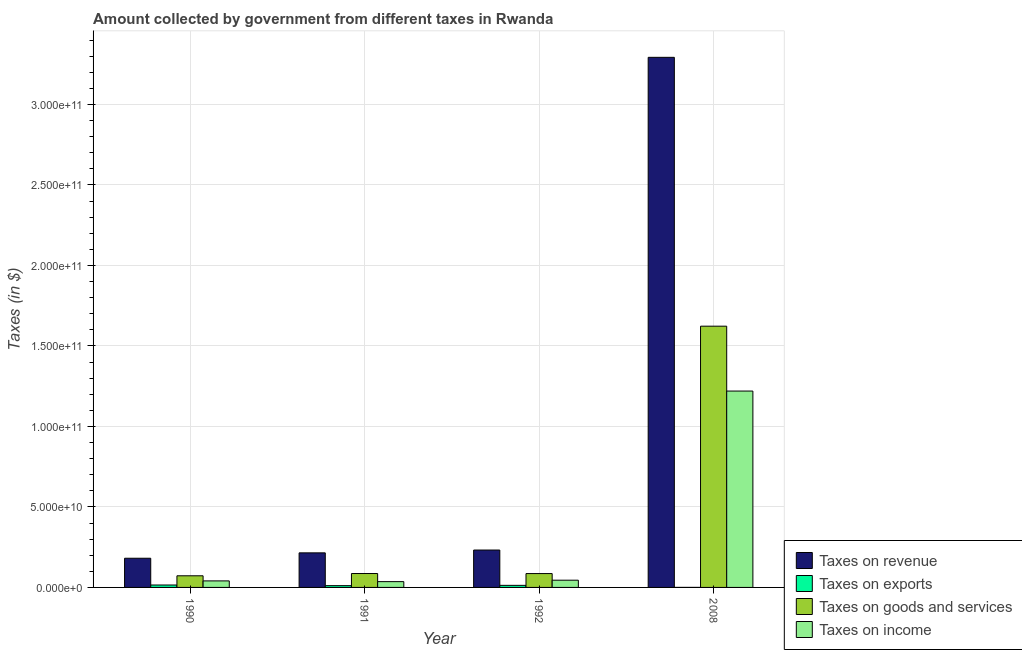How many different coloured bars are there?
Give a very brief answer. 4. How many groups of bars are there?
Offer a very short reply. 4. How many bars are there on the 2nd tick from the left?
Keep it short and to the point. 4. How many bars are there on the 3rd tick from the right?
Provide a succinct answer. 4. What is the amount collected as tax on income in 1992?
Your response must be concise. 4.49e+09. Across all years, what is the maximum amount collected as tax on revenue?
Offer a terse response. 3.29e+11. Across all years, what is the minimum amount collected as tax on exports?
Give a very brief answer. 1.73e+07. In which year was the amount collected as tax on income minimum?
Provide a short and direct response. 1991. What is the total amount collected as tax on goods in the graph?
Provide a succinct answer. 1.87e+11. What is the difference between the amount collected as tax on revenue in 1992 and that in 2008?
Keep it short and to the point. -3.06e+11. What is the difference between the amount collected as tax on goods in 1992 and the amount collected as tax on income in 1990?
Make the answer very short. 1.38e+09. What is the average amount collected as tax on income per year?
Your answer should be very brief. 3.35e+1. What is the ratio of the amount collected as tax on income in 1992 to that in 2008?
Your answer should be very brief. 0.04. Is the difference between the amount collected as tax on exports in 1991 and 1992 greater than the difference between the amount collected as tax on income in 1991 and 1992?
Your response must be concise. No. What is the difference between the highest and the second highest amount collected as tax on exports?
Your answer should be very brief. 2.14e+08. What is the difference between the highest and the lowest amount collected as tax on goods?
Give a very brief answer. 1.55e+11. In how many years, is the amount collected as tax on exports greater than the average amount collected as tax on exports taken over all years?
Provide a short and direct response. 3. Is the sum of the amount collected as tax on revenue in 1991 and 2008 greater than the maximum amount collected as tax on exports across all years?
Make the answer very short. Yes. Is it the case that in every year, the sum of the amount collected as tax on exports and amount collected as tax on income is greater than the sum of amount collected as tax on goods and amount collected as tax on revenue?
Offer a terse response. No. What does the 1st bar from the left in 1991 represents?
Give a very brief answer. Taxes on revenue. What does the 3rd bar from the right in 1990 represents?
Provide a succinct answer. Taxes on exports. Is it the case that in every year, the sum of the amount collected as tax on revenue and amount collected as tax on exports is greater than the amount collected as tax on goods?
Offer a very short reply. Yes. What is the difference between two consecutive major ticks on the Y-axis?
Give a very brief answer. 5.00e+1. Are the values on the major ticks of Y-axis written in scientific E-notation?
Provide a succinct answer. Yes. Does the graph contain grids?
Your answer should be very brief. Yes. Where does the legend appear in the graph?
Keep it short and to the point. Bottom right. How many legend labels are there?
Provide a succinct answer. 4. What is the title of the graph?
Provide a short and direct response. Amount collected by government from different taxes in Rwanda. Does "Natural Gas" appear as one of the legend labels in the graph?
Your response must be concise. No. What is the label or title of the Y-axis?
Offer a terse response. Taxes (in $). What is the Taxes (in $) of Taxes on revenue in 1990?
Ensure brevity in your answer.  1.81e+1. What is the Taxes (in $) in Taxes on exports in 1990?
Offer a terse response. 1.51e+09. What is the Taxes (in $) in Taxes on goods and services in 1990?
Your answer should be compact. 7.23e+09. What is the Taxes (in $) in Taxes on income in 1990?
Provide a short and direct response. 4.06e+09. What is the Taxes (in $) of Taxes on revenue in 1991?
Offer a terse response. 2.15e+1. What is the Taxes (in $) of Taxes on exports in 1991?
Your answer should be very brief. 1.11e+09. What is the Taxes (in $) in Taxes on goods and services in 1991?
Offer a terse response. 8.63e+09. What is the Taxes (in $) of Taxes on income in 1991?
Provide a short and direct response. 3.60e+09. What is the Taxes (in $) of Taxes on revenue in 1992?
Ensure brevity in your answer.  2.32e+1. What is the Taxes (in $) of Taxes on exports in 1992?
Your answer should be compact. 1.29e+09. What is the Taxes (in $) in Taxes on goods and services in 1992?
Ensure brevity in your answer.  8.60e+09. What is the Taxes (in $) in Taxes on income in 1992?
Your response must be concise. 4.49e+09. What is the Taxes (in $) in Taxes on revenue in 2008?
Ensure brevity in your answer.  3.29e+11. What is the Taxes (in $) in Taxes on exports in 2008?
Your answer should be very brief. 1.73e+07. What is the Taxes (in $) of Taxes on goods and services in 2008?
Keep it short and to the point. 1.62e+11. What is the Taxes (in $) in Taxes on income in 2008?
Your answer should be very brief. 1.22e+11. Across all years, what is the maximum Taxes (in $) in Taxes on revenue?
Make the answer very short. 3.29e+11. Across all years, what is the maximum Taxes (in $) in Taxes on exports?
Provide a short and direct response. 1.51e+09. Across all years, what is the maximum Taxes (in $) of Taxes on goods and services?
Ensure brevity in your answer.  1.62e+11. Across all years, what is the maximum Taxes (in $) in Taxes on income?
Your answer should be very brief. 1.22e+11. Across all years, what is the minimum Taxes (in $) of Taxes on revenue?
Ensure brevity in your answer.  1.81e+1. Across all years, what is the minimum Taxes (in $) of Taxes on exports?
Give a very brief answer. 1.73e+07. Across all years, what is the minimum Taxes (in $) in Taxes on goods and services?
Provide a succinct answer. 7.23e+09. Across all years, what is the minimum Taxes (in $) in Taxes on income?
Your response must be concise. 3.60e+09. What is the total Taxes (in $) in Taxes on revenue in the graph?
Ensure brevity in your answer.  3.92e+11. What is the total Taxes (in $) in Taxes on exports in the graph?
Make the answer very short. 3.92e+09. What is the total Taxes (in $) in Taxes on goods and services in the graph?
Ensure brevity in your answer.  1.87e+11. What is the total Taxes (in $) of Taxes on income in the graph?
Ensure brevity in your answer.  1.34e+11. What is the difference between the Taxes (in $) of Taxes on revenue in 1990 and that in 1991?
Your answer should be very brief. -3.34e+09. What is the difference between the Taxes (in $) in Taxes on exports in 1990 and that in 1991?
Make the answer very short. 3.99e+08. What is the difference between the Taxes (in $) of Taxes on goods and services in 1990 and that in 1991?
Your answer should be compact. -1.40e+09. What is the difference between the Taxes (in $) in Taxes on income in 1990 and that in 1991?
Give a very brief answer. 4.54e+08. What is the difference between the Taxes (in $) in Taxes on revenue in 1990 and that in 1992?
Offer a terse response. -5.09e+09. What is the difference between the Taxes (in $) in Taxes on exports in 1990 and that in 1992?
Your answer should be compact. 2.14e+08. What is the difference between the Taxes (in $) of Taxes on goods and services in 1990 and that in 1992?
Your answer should be very brief. -1.38e+09. What is the difference between the Taxes (in $) in Taxes on income in 1990 and that in 1992?
Ensure brevity in your answer.  -4.31e+08. What is the difference between the Taxes (in $) in Taxes on revenue in 1990 and that in 2008?
Provide a succinct answer. -3.11e+11. What is the difference between the Taxes (in $) in Taxes on exports in 1990 and that in 2008?
Give a very brief answer. 1.49e+09. What is the difference between the Taxes (in $) of Taxes on goods and services in 1990 and that in 2008?
Provide a short and direct response. -1.55e+11. What is the difference between the Taxes (in $) in Taxes on income in 1990 and that in 2008?
Your answer should be very brief. -1.18e+11. What is the difference between the Taxes (in $) in Taxes on revenue in 1991 and that in 1992?
Provide a short and direct response. -1.75e+09. What is the difference between the Taxes (in $) of Taxes on exports in 1991 and that in 1992?
Your answer should be very brief. -1.85e+08. What is the difference between the Taxes (in $) in Taxes on goods and services in 1991 and that in 1992?
Provide a succinct answer. 2.90e+07. What is the difference between the Taxes (in $) in Taxes on income in 1991 and that in 1992?
Your answer should be very brief. -8.85e+08. What is the difference between the Taxes (in $) of Taxes on revenue in 1991 and that in 2008?
Offer a terse response. -3.08e+11. What is the difference between the Taxes (in $) in Taxes on exports in 1991 and that in 2008?
Offer a terse response. 1.09e+09. What is the difference between the Taxes (in $) of Taxes on goods and services in 1991 and that in 2008?
Offer a terse response. -1.54e+11. What is the difference between the Taxes (in $) of Taxes on income in 1991 and that in 2008?
Give a very brief answer. -1.18e+11. What is the difference between the Taxes (in $) in Taxes on revenue in 1992 and that in 2008?
Make the answer very short. -3.06e+11. What is the difference between the Taxes (in $) in Taxes on exports in 1992 and that in 2008?
Give a very brief answer. 1.27e+09. What is the difference between the Taxes (in $) of Taxes on goods and services in 1992 and that in 2008?
Offer a terse response. -1.54e+11. What is the difference between the Taxes (in $) of Taxes on income in 1992 and that in 2008?
Keep it short and to the point. -1.17e+11. What is the difference between the Taxes (in $) in Taxes on revenue in 1990 and the Taxes (in $) in Taxes on exports in 1991?
Give a very brief answer. 1.70e+1. What is the difference between the Taxes (in $) in Taxes on revenue in 1990 and the Taxes (in $) in Taxes on goods and services in 1991?
Your response must be concise. 9.50e+09. What is the difference between the Taxes (in $) of Taxes on revenue in 1990 and the Taxes (in $) of Taxes on income in 1991?
Keep it short and to the point. 1.45e+1. What is the difference between the Taxes (in $) of Taxes on exports in 1990 and the Taxes (in $) of Taxes on goods and services in 1991?
Your answer should be very brief. -7.13e+09. What is the difference between the Taxes (in $) of Taxes on exports in 1990 and the Taxes (in $) of Taxes on income in 1991?
Make the answer very short. -2.10e+09. What is the difference between the Taxes (in $) of Taxes on goods and services in 1990 and the Taxes (in $) of Taxes on income in 1991?
Your answer should be compact. 3.63e+09. What is the difference between the Taxes (in $) of Taxes on revenue in 1990 and the Taxes (in $) of Taxes on exports in 1992?
Give a very brief answer. 1.68e+1. What is the difference between the Taxes (in $) of Taxes on revenue in 1990 and the Taxes (in $) of Taxes on goods and services in 1992?
Provide a succinct answer. 9.52e+09. What is the difference between the Taxes (in $) of Taxes on revenue in 1990 and the Taxes (in $) of Taxes on income in 1992?
Provide a short and direct response. 1.36e+1. What is the difference between the Taxes (in $) of Taxes on exports in 1990 and the Taxes (in $) of Taxes on goods and services in 1992?
Provide a short and direct response. -7.10e+09. What is the difference between the Taxes (in $) in Taxes on exports in 1990 and the Taxes (in $) in Taxes on income in 1992?
Provide a succinct answer. -2.98e+09. What is the difference between the Taxes (in $) in Taxes on goods and services in 1990 and the Taxes (in $) in Taxes on income in 1992?
Make the answer very short. 2.74e+09. What is the difference between the Taxes (in $) of Taxes on revenue in 1990 and the Taxes (in $) of Taxes on exports in 2008?
Make the answer very short. 1.81e+1. What is the difference between the Taxes (in $) of Taxes on revenue in 1990 and the Taxes (in $) of Taxes on goods and services in 2008?
Offer a very short reply. -1.44e+11. What is the difference between the Taxes (in $) of Taxes on revenue in 1990 and the Taxes (in $) of Taxes on income in 2008?
Ensure brevity in your answer.  -1.04e+11. What is the difference between the Taxes (in $) in Taxes on exports in 1990 and the Taxes (in $) in Taxes on goods and services in 2008?
Make the answer very short. -1.61e+11. What is the difference between the Taxes (in $) of Taxes on exports in 1990 and the Taxes (in $) of Taxes on income in 2008?
Make the answer very short. -1.20e+11. What is the difference between the Taxes (in $) of Taxes on goods and services in 1990 and the Taxes (in $) of Taxes on income in 2008?
Your response must be concise. -1.15e+11. What is the difference between the Taxes (in $) in Taxes on revenue in 1991 and the Taxes (in $) in Taxes on exports in 1992?
Offer a very short reply. 2.02e+1. What is the difference between the Taxes (in $) in Taxes on revenue in 1991 and the Taxes (in $) in Taxes on goods and services in 1992?
Offer a very short reply. 1.29e+1. What is the difference between the Taxes (in $) of Taxes on revenue in 1991 and the Taxes (in $) of Taxes on income in 1992?
Keep it short and to the point. 1.70e+1. What is the difference between the Taxes (in $) of Taxes on exports in 1991 and the Taxes (in $) of Taxes on goods and services in 1992?
Keep it short and to the point. -7.50e+09. What is the difference between the Taxes (in $) in Taxes on exports in 1991 and the Taxes (in $) in Taxes on income in 1992?
Provide a succinct answer. -3.38e+09. What is the difference between the Taxes (in $) of Taxes on goods and services in 1991 and the Taxes (in $) of Taxes on income in 1992?
Your response must be concise. 4.14e+09. What is the difference between the Taxes (in $) in Taxes on revenue in 1991 and the Taxes (in $) in Taxes on exports in 2008?
Provide a short and direct response. 2.15e+1. What is the difference between the Taxes (in $) in Taxes on revenue in 1991 and the Taxes (in $) in Taxes on goods and services in 2008?
Keep it short and to the point. -1.41e+11. What is the difference between the Taxes (in $) in Taxes on revenue in 1991 and the Taxes (in $) in Taxes on income in 2008?
Give a very brief answer. -1.00e+11. What is the difference between the Taxes (in $) of Taxes on exports in 1991 and the Taxes (in $) of Taxes on goods and services in 2008?
Your answer should be compact. -1.61e+11. What is the difference between the Taxes (in $) of Taxes on exports in 1991 and the Taxes (in $) of Taxes on income in 2008?
Offer a terse response. -1.21e+11. What is the difference between the Taxes (in $) in Taxes on goods and services in 1991 and the Taxes (in $) in Taxes on income in 2008?
Provide a short and direct response. -1.13e+11. What is the difference between the Taxes (in $) of Taxes on revenue in 1992 and the Taxes (in $) of Taxes on exports in 2008?
Your answer should be very brief. 2.32e+1. What is the difference between the Taxes (in $) of Taxes on revenue in 1992 and the Taxes (in $) of Taxes on goods and services in 2008?
Provide a succinct answer. -1.39e+11. What is the difference between the Taxes (in $) of Taxes on revenue in 1992 and the Taxes (in $) of Taxes on income in 2008?
Keep it short and to the point. -9.87e+1. What is the difference between the Taxes (in $) in Taxes on exports in 1992 and the Taxes (in $) in Taxes on goods and services in 2008?
Offer a very short reply. -1.61e+11. What is the difference between the Taxes (in $) in Taxes on exports in 1992 and the Taxes (in $) in Taxes on income in 2008?
Offer a very short reply. -1.21e+11. What is the difference between the Taxes (in $) in Taxes on goods and services in 1992 and the Taxes (in $) in Taxes on income in 2008?
Provide a succinct answer. -1.13e+11. What is the average Taxes (in $) of Taxes on revenue per year?
Offer a very short reply. 9.80e+1. What is the average Taxes (in $) in Taxes on exports per year?
Offer a terse response. 9.81e+08. What is the average Taxes (in $) in Taxes on goods and services per year?
Keep it short and to the point. 4.67e+1. What is the average Taxes (in $) in Taxes on income per year?
Offer a terse response. 3.35e+1. In the year 1990, what is the difference between the Taxes (in $) in Taxes on revenue and Taxes (in $) in Taxes on exports?
Offer a very short reply. 1.66e+1. In the year 1990, what is the difference between the Taxes (in $) of Taxes on revenue and Taxes (in $) of Taxes on goods and services?
Your answer should be very brief. 1.09e+1. In the year 1990, what is the difference between the Taxes (in $) in Taxes on revenue and Taxes (in $) in Taxes on income?
Your response must be concise. 1.41e+1. In the year 1990, what is the difference between the Taxes (in $) in Taxes on exports and Taxes (in $) in Taxes on goods and services?
Ensure brevity in your answer.  -5.72e+09. In the year 1990, what is the difference between the Taxes (in $) in Taxes on exports and Taxes (in $) in Taxes on income?
Keep it short and to the point. -2.55e+09. In the year 1990, what is the difference between the Taxes (in $) in Taxes on goods and services and Taxes (in $) in Taxes on income?
Provide a short and direct response. 3.17e+09. In the year 1991, what is the difference between the Taxes (in $) in Taxes on revenue and Taxes (in $) in Taxes on exports?
Ensure brevity in your answer.  2.04e+1. In the year 1991, what is the difference between the Taxes (in $) of Taxes on revenue and Taxes (in $) of Taxes on goods and services?
Your answer should be compact. 1.28e+1. In the year 1991, what is the difference between the Taxes (in $) in Taxes on revenue and Taxes (in $) in Taxes on income?
Your answer should be compact. 1.79e+1. In the year 1991, what is the difference between the Taxes (in $) in Taxes on exports and Taxes (in $) in Taxes on goods and services?
Provide a succinct answer. -7.52e+09. In the year 1991, what is the difference between the Taxes (in $) in Taxes on exports and Taxes (in $) in Taxes on income?
Your response must be concise. -2.50e+09. In the year 1991, what is the difference between the Taxes (in $) in Taxes on goods and services and Taxes (in $) in Taxes on income?
Provide a succinct answer. 5.03e+09. In the year 1992, what is the difference between the Taxes (in $) in Taxes on revenue and Taxes (in $) in Taxes on exports?
Your answer should be very brief. 2.19e+1. In the year 1992, what is the difference between the Taxes (in $) of Taxes on revenue and Taxes (in $) of Taxes on goods and services?
Ensure brevity in your answer.  1.46e+1. In the year 1992, what is the difference between the Taxes (in $) in Taxes on revenue and Taxes (in $) in Taxes on income?
Provide a short and direct response. 1.87e+1. In the year 1992, what is the difference between the Taxes (in $) in Taxes on exports and Taxes (in $) in Taxes on goods and services?
Keep it short and to the point. -7.31e+09. In the year 1992, what is the difference between the Taxes (in $) in Taxes on exports and Taxes (in $) in Taxes on income?
Provide a succinct answer. -3.20e+09. In the year 1992, what is the difference between the Taxes (in $) in Taxes on goods and services and Taxes (in $) in Taxes on income?
Make the answer very short. 4.12e+09. In the year 2008, what is the difference between the Taxes (in $) of Taxes on revenue and Taxes (in $) of Taxes on exports?
Offer a very short reply. 3.29e+11. In the year 2008, what is the difference between the Taxes (in $) of Taxes on revenue and Taxes (in $) of Taxes on goods and services?
Make the answer very short. 1.67e+11. In the year 2008, what is the difference between the Taxes (in $) in Taxes on revenue and Taxes (in $) in Taxes on income?
Offer a terse response. 2.07e+11. In the year 2008, what is the difference between the Taxes (in $) of Taxes on exports and Taxes (in $) of Taxes on goods and services?
Provide a succinct answer. -1.62e+11. In the year 2008, what is the difference between the Taxes (in $) in Taxes on exports and Taxes (in $) in Taxes on income?
Give a very brief answer. -1.22e+11. In the year 2008, what is the difference between the Taxes (in $) in Taxes on goods and services and Taxes (in $) in Taxes on income?
Your response must be concise. 4.03e+1. What is the ratio of the Taxes (in $) in Taxes on revenue in 1990 to that in 1991?
Your answer should be very brief. 0.84. What is the ratio of the Taxes (in $) of Taxes on exports in 1990 to that in 1991?
Your answer should be compact. 1.36. What is the ratio of the Taxes (in $) of Taxes on goods and services in 1990 to that in 1991?
Provide a short and direct response. 0.84. What is the ratio of the Taxes (in $) of Taxes on income in 1990 to that in 1991?
Make the answer very short. 1.13. What is the ratio of the Taxes (in $) in Taxes on revenue in 1990 to that in 1992?
Your answer should be very brief. 0.78. What is the ratio of the Taxes (in $) in Taxes on exports in 1990 to that in 1992?
Your answer should be very brief. 1.17. What is the ratio of the Taxes (in $) in Taxes on goods and services in 1990 to that in 1992?
Ensure brevity in your answer.  0.84. What is the ratio of the Taxes (in $) in Taxes on income in 1990 to that in 1992?
Give a very brief answer. 0.9. What is the ratio of the Taxes (in $) of Taxes on revenue in 1990 to that in 2008?
Offer a terse response. 0.06. What is the ratio of the Taxes (in $) of Taxes on exports in 1990 to that in 2008?
Provide a short and direct response. 87.09. What is the ratio of the Taxes (in $) in Taxes on goods and services in 1990 to that in 2008?
Make the answer very short. 0.04. What is the ratio of the Taxes (in $) of Taxes on income in 1990 to that in 2008?
Provide a succinct answer. 0.03. What is the ratio of the Taxes (in $) in Taxes on revenue in 1991 to that in 1992?
Your response must be concise. 0.92. What is the ratio of the Taxes (in $) in Taxes on exports in 1991 to that in 1992?
Make the answer very short. 0.86. What is the ratio of the Taxes (in $) of Taxes on income in 1991 to that in 1992?
Give a very brief answer. 0.8. What is the ratio of the Taxes (in $) in Taxes on revenue in 1991 to that in 2008?
Keep it short and to the point. 0.07. What is the ratio of the Taxes (in $) of Taxes on exports in 1991 to that in 2008?
Your answer should be very brief. 64.02. What is the ratio of the Taxes (in $) in Taxes on goods and services in 1991 to that in 2008?
Your answer should be compact. 0.05. What is the ratio of the Taxes (in $) in Taxes on income in 1991 to that in 2008?
Your answer should be very brief. 0.03. What is the ratio of the Taxes (in $) in Taxes on revenue in 1992 to that in 2008?
Your response must be concise. 0.07. What is the ratio of the Taxes (in $) of Taxes on exports in 1992 to that in 2008?
Ensure brevity in your answer.  74.72. What is the ratio of the Taxes (in $) in Taxes on goods and services in 1992 to that in 2008?
Make the answer very short. 0.05. What is the ratio of the Taxes (in $) of Taxes on income in 1992 to that in 2008?
Offer a terse response. 0.04. What is the difference between the highest and the second highest Taxes (in $) in Taxes on revenue?
Provide a succinct answer. 3.06e+11. What is the difference between the highest and the second highest Taxes (in $) of Taxes on exports?
Make the answer very short. 2.14e+08. What is the difference between the highest and the second highest Taxes (in $) in Taxes on goods and services?
Give a very brief answer. 1.54e+11. What is the difference between the highest and the second highest Taxes (in $) in Taxes on income?
Provide a succinct answer. 1.17e+11. What is the difference between the highest and the lowest Taxes (in $) of Taxes on revenue?
Make the answer very short. 3.11e+11. What is the difference between the highest and the lowest Taxes (in $) in Taxes on exports?
Offer a terse response. 1.49e+09. What is the difference between the highest and the lowest Taxes (in $) in Taxes on goods and services?
Your answer should be compact. 1.55e+11. What is the difference between the highest and the lowest Taxes (in $) in Taxes on income?
Provide a short and direct response. 1.18e+11. 